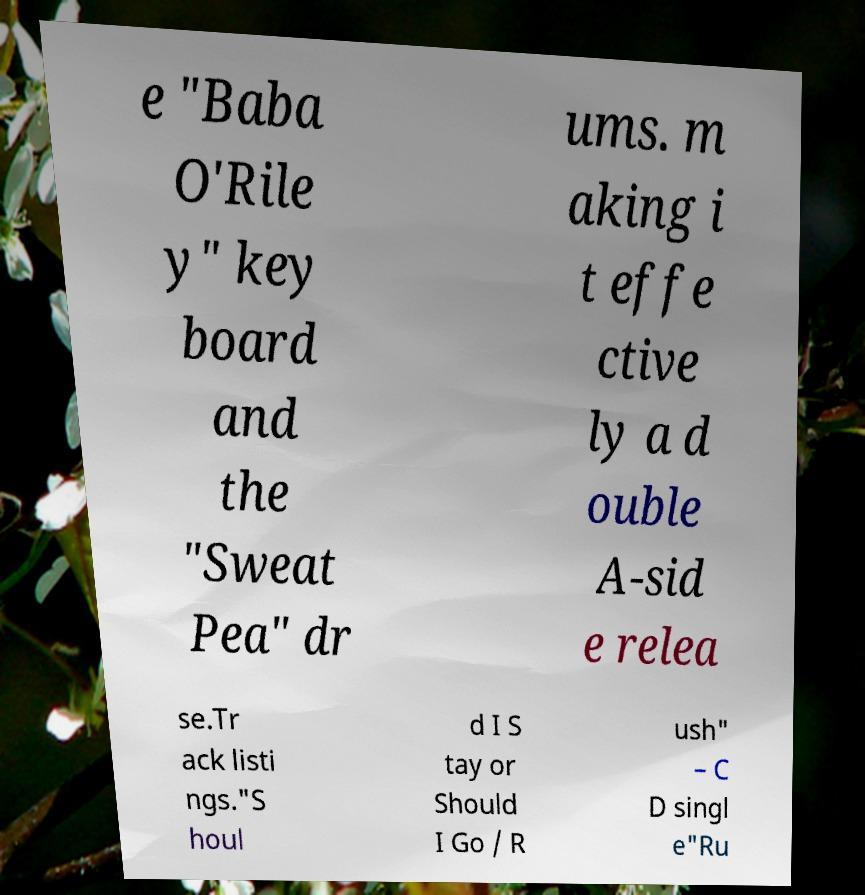What messages or text are displayed in this image? I need them in a readable, typed format. e "Baba O'Rile y" key board and the "Sweat Pea" dr ums. m aking i t effe ctive ly a d ouble A-sid e relea se.Tr ack listi ngs."S houl d I S tay or Should I Go / R ush" – C D singl e"Ru 